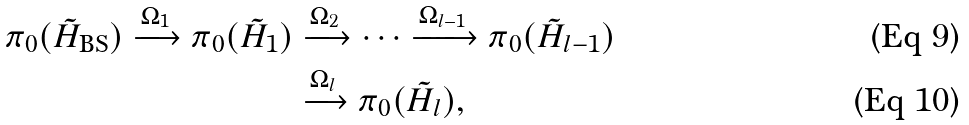Convert formula to latex. <formula><loc_0><loc_0><loc_500><loc_500>\pi _ { 0 } ( \tilde { H } _ { \text {BS} } ) \xrightarrow { \Omega _ { 1 } } \pi _ { 0 } ( \tilde { H } _ { 1 } ) & \xrightarrow { \Omega _ { 2 } } \cdots \xrightarrow { \Omega _ { l - 1 } } \pi _ { 0 } ( \tilde { H } _ { l - 1 } ) \\ & \xrightarrow { \Omega _ { l } } \pi _ { 0 } ( \tilde { H } _ { l } ) ,</formula> 